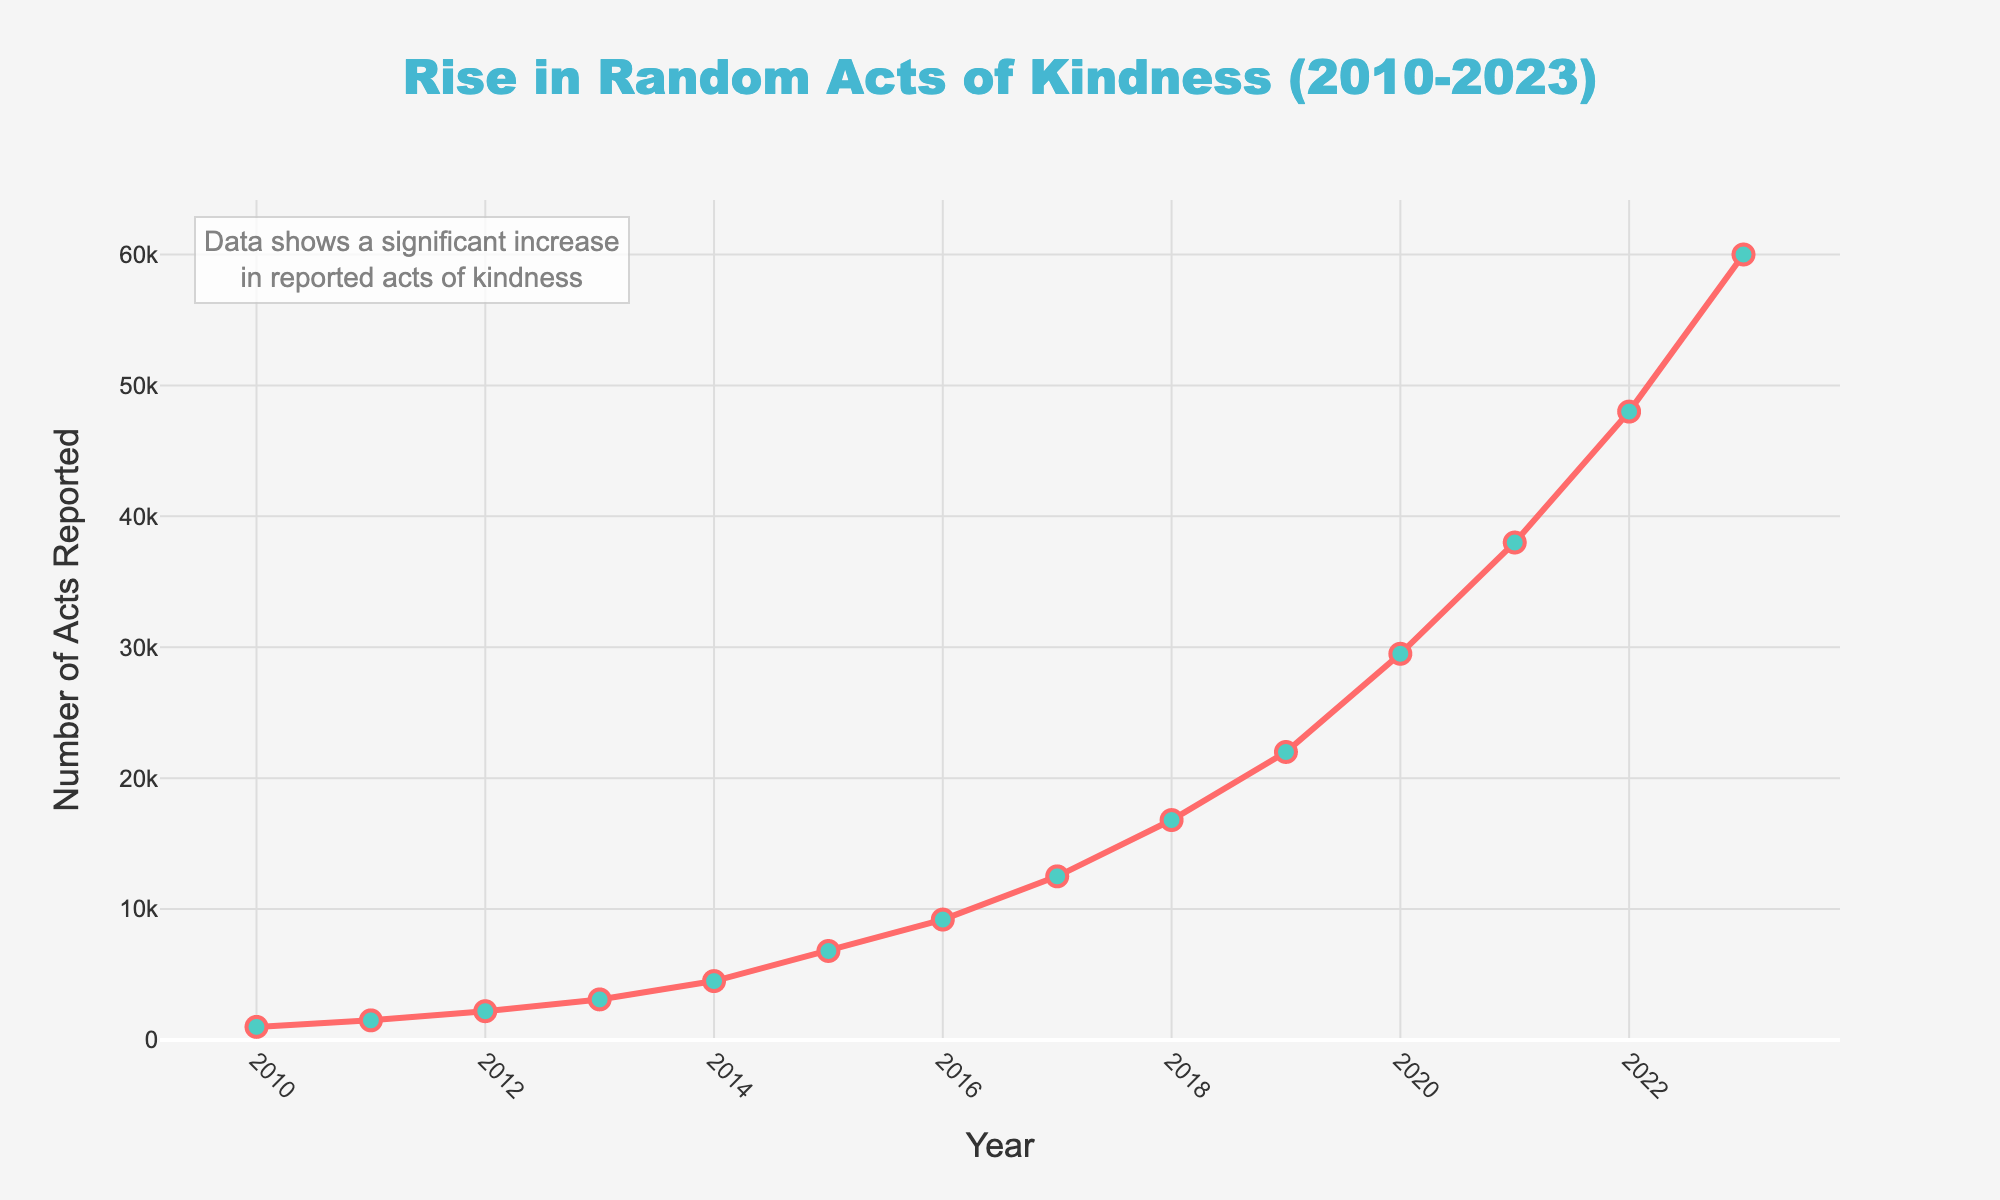What is the number of random acts of kindness reported in 2023? To find the number of random acts of kindness reported in 2023, locate the value on the y-axis corresponding to the year 2023 on the x-axis.
Answer: 60000 How did the number of acts reported in 2015 compare to those in 2014? Compare the values on the y-axis for the years 2014 and 2015. The number of acts reported in 2015 (6800) is higher than in 2014 (4500).
Answer: Higher What is the difference in the number of acts reported between 2010 and 2019? Subtract the number of acts reported in 2010 (1000) from the number in 2019 (22000): 22000 - 1000 = 21000.
Answer: 21000 How much did the number of reported acts increase from 2020 to 2023? Subtract the 2020 value (29500) from the 2023 value (60000): 60000 - 29500 = 30500.
Answer: 30500 Which year saw the highest jump in the number of reported acts compared to the previous year? Calculate the year-to-year differences and identify the year with the largest increase. The jump between 2019 (22000) and 2020 (29500) is the largest with an increase of 7500.
Answer: 2020 What is the average number of random acts of kindness reported from 2010 to 2015? Add the values from 2010 to 2015 and divide by the number of years (6): (1000 + 1500 + 2200 + 3100 + 4500 + 6800) / 6 = 3183.33.
Answer: 3183.33 By what factor did the reported acts increase from 2010 to 2023? Divide the number of reported acts in 2023 (60000) by the number in 2010 (1000): 60000 / 1000 = 60.
Answer: 60 Looking at the trend, which decade shows a more significant increase in reported acts: 2010-2019 or 2020-2023? Measure the increase from 2010 to 2019 (22000 - 1000 = 21000) and from 2020 to 2023 (60000 - 29500 = 30500). The decade 2020-2023 shows a more significant increase.
Answer: 2020-2023 